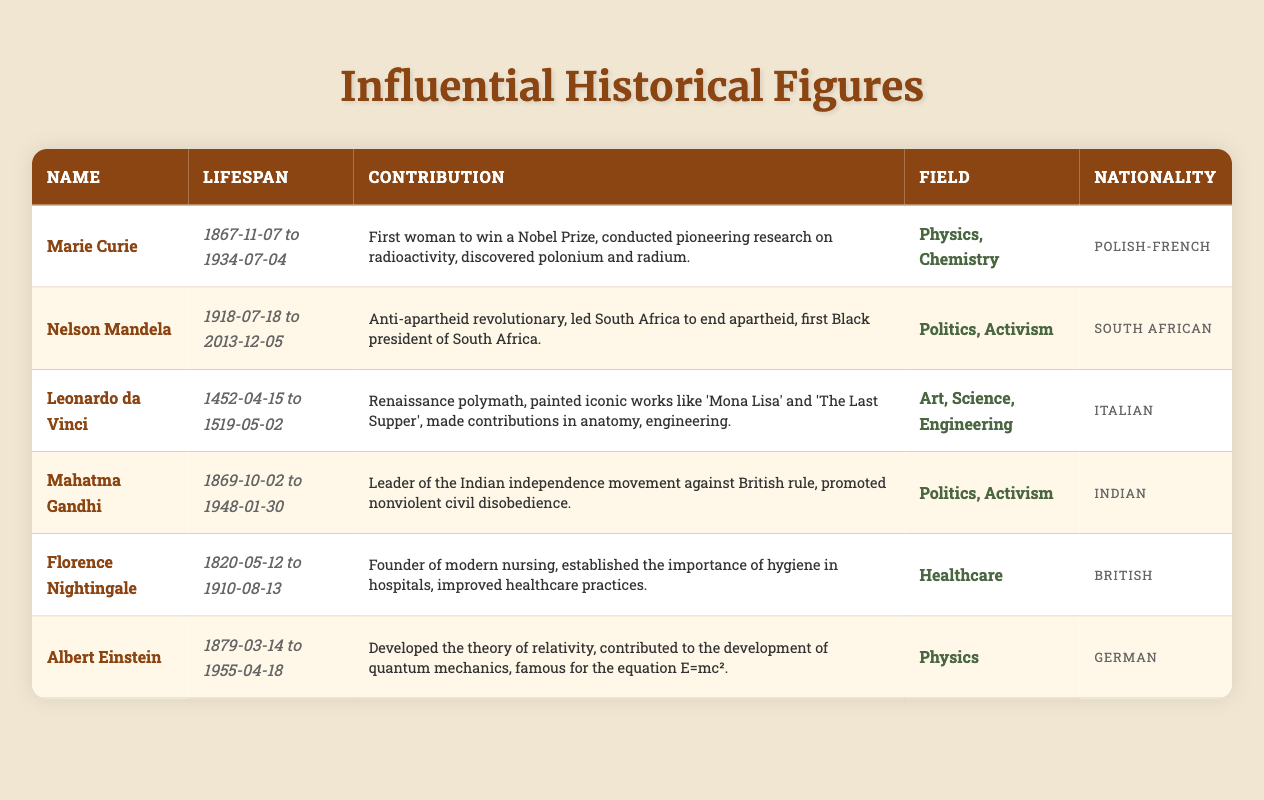What is the contribution of Marie Curie? Marie Curie is known for being the first woman to win a Nobel Prize. She conducted pioneering research on radioactivity and discovered the elements polonium and radium.
Answer: First woman to win a Nobel Prize, conducted pioneering research on radioactivity, discovered polonium and radium Who was the first Black president of South Africa? According to the table, Nelson Mandela is named as the first Black president of South Africa after leading the country to end apartheid.
Answer: Nelson Mandela Which figure was a founder of modern nursing? The table indicates that Florence Nightingale is recognized as the founder of modern nursing, having established the importance of hygiene in hospitals.
Answer: Florence Nightingale How many historical figures were involved in politics or activism? There are three figures in the table associated with politics or activism: Nelson Mandela, Mahatma Gandhi, and Florence Nightingale, which counts to three.
Answer: 3 Was Leonardo da Vinci involved in science? Yes, the table indicates that Leonardo da Vinci contributed not only in art but also in science and engineering, making him a Renaissance polymath.
Answer: Yes Which historical figure had the longest lifespan? By checking the dates of life for each figure: Marie Curie (66 years), Nelson Mandela (95 years), Leonardo da Vinci (67 years), Mahatma Gandhi (78 years), Florence Nightingale (90 years), Albert Einstein (76 years). Nelson Mandela lived the longest at 95 years.
Answer: Nelson Mandela List the nationalities of the historical figures who contributed to Physics. In the table, both Marie Curie and Albert Einstein contributed to Physics. Marie Curie’s nationality is Polish-French and Albert Einstein is German. Thus, the nationalities are "Polish-French, German."
Answer: Polish-French, German Who among these figures worked primarily in healthcare? Florence Nightingale is designated in the table as having worked primarily in healthcare, focusing on improving healthcare practices.
Answer: Florence Nightingale Calculate the average lifespan of the historical figures listed. The lifespans are calculated by taking their birth and death years: Marie Curie (66), Nelson Mandela (95), Leonardo da Vinci (67), Mahatma Gandhi (78), Florence Nightingale (90), Albert Einstein (76). Adding these gives a total of 472 years, then divided by 6 figures gives an average of approximately 78.67 years.
Answer: 78.67 